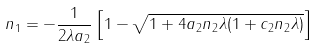<formula> <loc_0><loc_0><loc_500><loc_500>n _ { 1 } = - \frac { 1 } { 2 \lambda a _ { 2 } } \left [ 1 - \sqrt { 1 + 4 a _ { 2 } n _ { 2 } \lambda ( 1 + c _ { 2 } n _ { 2 } \lambda ) } \right ]</formula> 